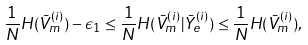Convert formula to latex. <formula><loc_0><loc_0><loc_500><loc_500>\frac { 1 } { N } H ( \bar { V } _ { m } ^ { ( i ) } ) - \epsilon _ { 1 } \leq \frac { 1 } { N } H ( \bar { V } _ { m } ^ { ( i ) } | \bar { Y } _ { e } ^ { ( i ) } ) \leq \frac { 1 } { N } H ( \bar { V } _ { m } ^ { ( i ) } ) ,</formula> 